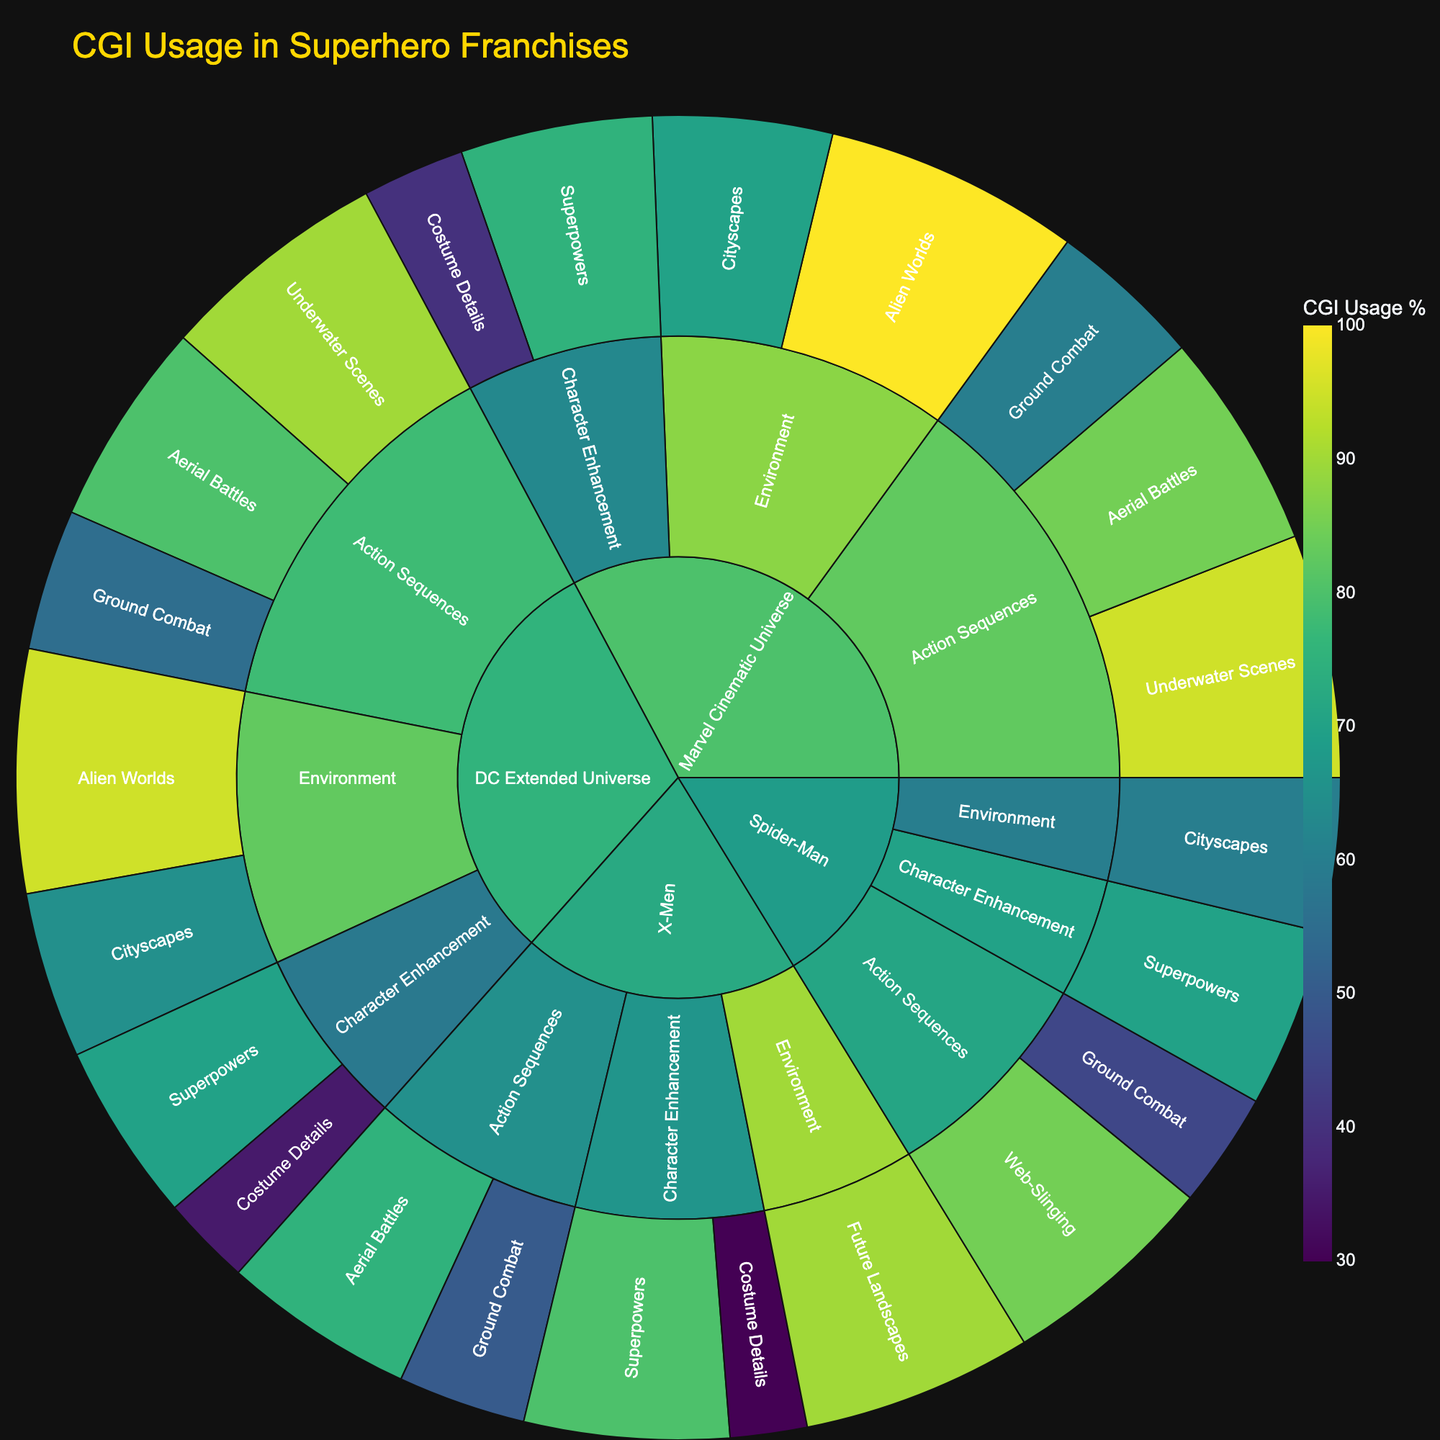What is the title of the figure? The title is often located at the top of the plot. In this case, it should state the main topic of the visualization.
Answer: CGI Usage in Superhero Franchises Which franchise has the highest CGI usage percentage for underwater scenes? To find this, look at the 'Underwater Scenes' section under the 'Action Sequences' category for each franchise. Compare the values for each one.
Answer: Marvel Cinematic Universe In the Marvel Cinematic Universe, what category has the scene type with the lowest CGI usage? First, locate all categories within the Marvel Cinematic Universe. Then, find which scene type has the lowest percentage and determine its category.
Answer: Character Enhancement What is the average CGI usage percentage for the 'Action Sequences' category in the Marvel Cinematic Universe? Identify the CGI percentages for 'Aerial Battles', 'Ground Combat', and 'Underwater Scenes'. Sum these percentages (85 + 60 + 95) and divide by the number of scene types (3) to find the average.
Answer: 80 Which franchise has greater CGI usage for 'Cityscapes', Marvel Cinematic Universe or Spider-Man? Compare the 'Cityscapes' CGI usage percentages for both franchises. Marvel Cinematic Universe is 70%, and Spider-Man is 60%.
Answer: Marvel Cinematic Universe How does the CGI usage for 'Costume Details' in the Marvel Cinematic Universe compare to that in the DC Extended Universe? Locate the 'Costume Details' CGI usage percentages for both franchises and compare them directly. Marvel Cinematic Universe is 40%, and DC Extended Universe is 35%.
Answer: Marvel Cinematic Universe greater For which franchise and scene type is the CGI usage exactly 100%? Look at all scene types for each franchise and identify if any has a CGI usage percentage of 100%.
Answer: Marvel Cinematic Universe, Alien Worlds What is the difference in CGI usage between 'Aerial Battles' and 'Ground Combat' in the X-Men franchise? Determine and subtract the CGI usage percentages for 'Ground Combat' from 'Aerial Battles' in the X-Men franchise. (75 - 50).
Answer: 25 Is 'Web-Slinging' listed under 'Action Sequences' for Spider-Man? Check the 'Action Sequences' category under the Spider-Man franchise to see if 'Web-Slinging' is included.
Answer: Yes 